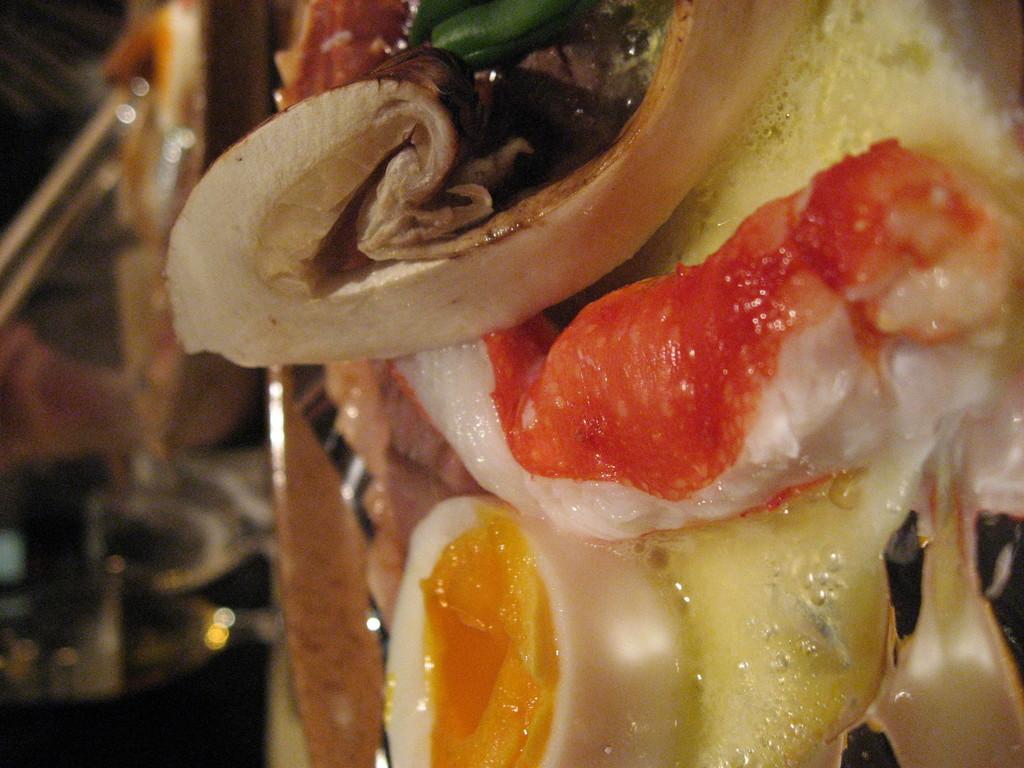Please provide a concise description of this image. In this picture we can see some food items and behind the food there are glasses, chopsticks and some blurred objects. 